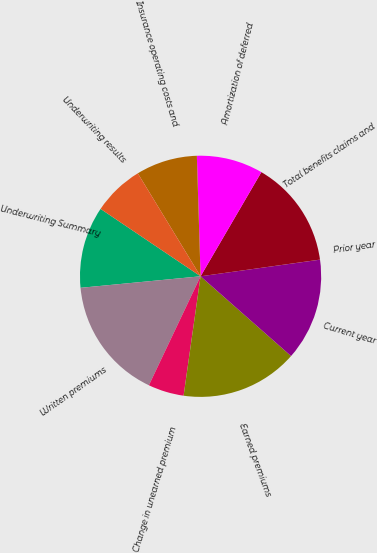Convert chart. <chart><loc_0><loc_0><loc_500><loc_500><pie_chart><fcel>Underwriting Summary<fcel>Written premiums<fcel>Change in unearned premium<fcel>Earned premiums<fcel>Current year<fcel>Prior year<fcel>Total benefits claims and<fcel>Amortization of deferred<fcel>Insurance operating costs and<fcel>Underwriting results<nl><fcel>10.96%<fcel>16.43%<fcel>4.8%<fcel>15.75%<fcel>13.7%<fcel>0.01%<fcel>14.38%<fcel>8.9%<fcel>8.22%<fcel>6.85%<nl></chart> 